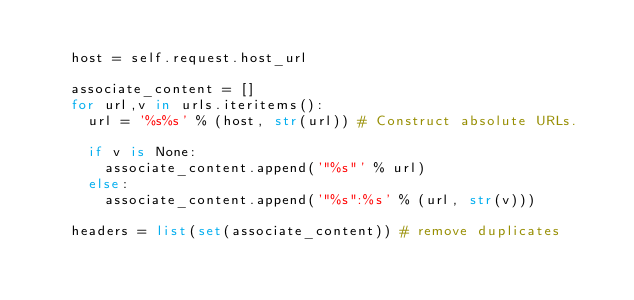<code> <loc_0><loc_0><loc_500><loc_500><_Python_>
    host = self.request.host_url

    associate_content = []
    for url,v in urls.iteritems():
      url = '%s%s' % (host, str(url)) # Construct absolute URLs.

      if v is None:
        associate_content.append('"%s"' % url)
      else:
        associate_content.append('"%s":%s' % (url, str(v)))

    headers = list(set(associate_content)) # remove duplicates
</code> 